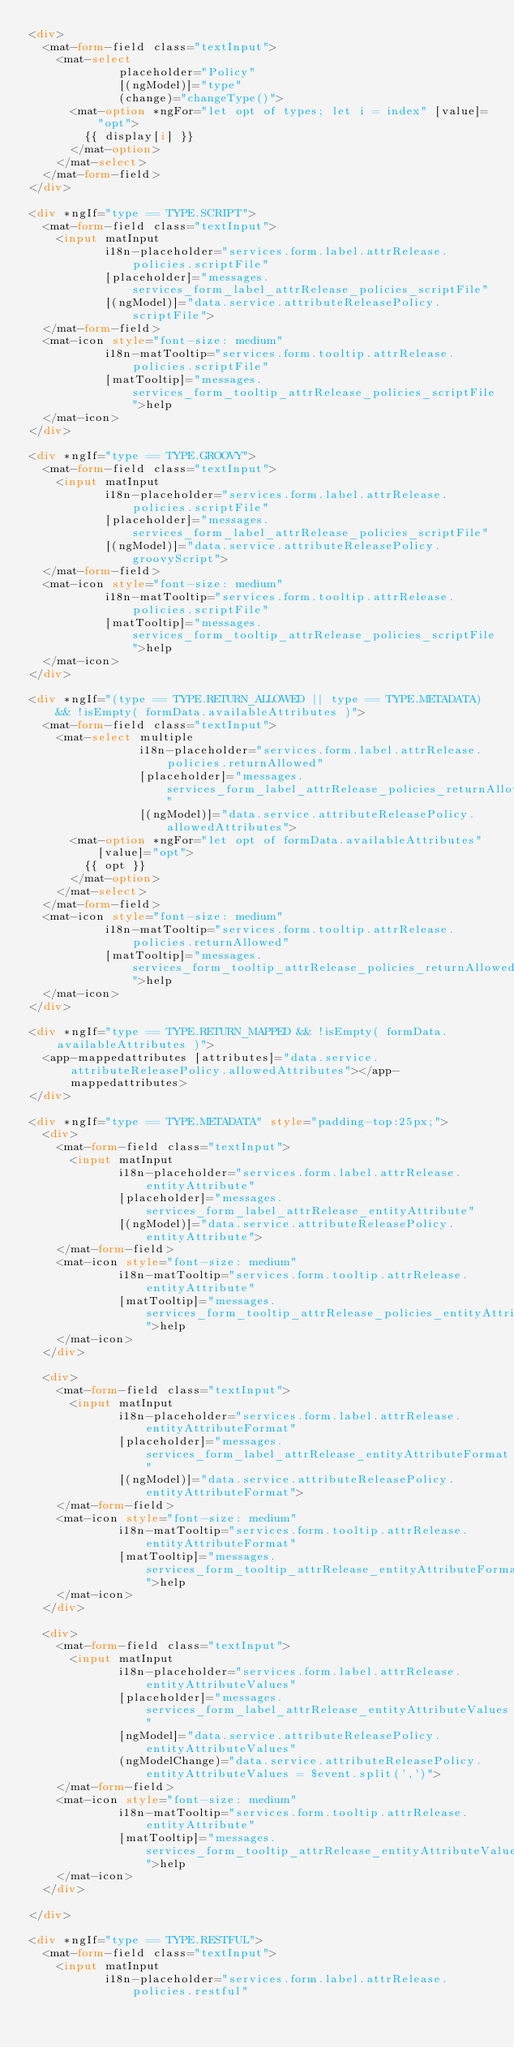<code> <loc_0><loc_0><loc_500><loc_500><_HTML_><div>
  <mat-form-field class="textInput">
    <mat-select
             placeholder="Policy"
             [(ngModel)]="type"
             (change)="changeType()">
      <mat-option *ngFor="let opt of types; let i = index" [value]="opt">
        {{ display[i] }}
      </mat-option>
    </mat-select>
  </mat-form-field>
</div>

<div *ngIf="type == TYPE.SCRIPT">
  <mat-form-field class="textInput">
    <input matInput
           i18n-placeholder="services.form.label.attrRelease.policies.scriptFile"
           [placeholder]="messages.services_form_label_attrRelease_policies_scriptFile"
           [(ngModel)]="data.service.attributeReleasePolicy.scriptFile">
  </mat-form-field>
  <mat-icon style="font-size: medium"
           i18n-matTooltip="services.form.tooltip.attrRelease.policies.scriptFile"
           [matTooltip]="messages.services_form_tooltip_attrRelease_policies_scriptFile">help
  </mat-icon>
</div>

<div *ngIf="type == TYPE.GROOVY">
  <mat-form-field class="textInput">
    <input matInput
           i18n-placeholder="services.form.label.attrRelease.policies.scriptFile"
           [placeholder]="messages.services_form_label_attrRelease_policies_scriptFile"
           [(ngModel)]="data.service.attributeReleasePolicy.groovyScript">
  </mat-form-field>
  <mat-icon style="font-size: medium"
           i18n-matTooltip="services.form.tooltip.attrRelease.policies.scriptFile"
           [matTooltip]="messages.services_form_tooltip_attrRelease_policies_scriptFile">help
  </mat-icon>
</div>

<div *ngIf="(type == TYPE.RETURN_ALLOWED || type == TYPE.METADATA) && !isEmpty( formData.availableAttributes )">
  <mat-form-field class="textInput">
    <mat-select multiple
                i18n-placeholder="services.form.label.attrRelease.policies.returnAllowed"
                [placeholder]="messages.services_form_label_attrRelease_policies_returnAllowed"
                [(ngModel)]="data.service.attributeReleasePolicy.allowedAttributes">
      <mat-option *ngFor="let opt of formData.availableAttributes" [value]="opt">
        {{ opt }}
      </mat-option>
    </mat-select>
  </mat-form-field>
  <mat-icon style="font-size: medium"
           i18n-matTooltip="services.form.tooltip.attrRelease.policies.returnAllowed"
           [matTooltip]="messages.services_form_tooltip_attrRelease_policies_returnAllowed">help
  </mat-icon>
</div>

<div *ngIf="type == TYPE.RETURN_MAPPED && !isEmpty( formData.availableAttributes )">
  <app-mappedattributes [attributes]="data.service.attributeReleasePolicy.allowedAttributes"></app-mappedattributes>
</div>

<div *ngIf="type == TYPE.METADATA" style="padding-top:25px;">
  <div>
    <mat-form-field class="textInput">
      <input matInput
             i18n-placeholder="services.form.label.attrRelease.entityAttribute"
             [placeholder]="messages.services_form_label_attrRelease_entityAttribute"
             [(ngModel)]="data.service.attributeReleasePolicy.entityAttribute">
    </mat-form-field>
    <mat-icon style="font-size: medium"
             i18n-matTooltip="services.form.tooltip.attrRelease.entityAttribute"
             [matTooltip]="messages.services_form_tooltip_attrRelease_policies_entityAttribute">help
    </mat-icon>
  </div>

  <div>
    <mat-form-field class="textInput">
      <input matInput
             i18n-placeholder="services.form.label.attrRelease.entityAttributeFormat"
             [placeholder]="messages.services_form_label_attrRelease_entityAttributeFormat"
             [(ngModel)]="data.service.attributeReleasePolicy.entityAttributeFormat">
    </mat-form-field>
    <mat-icon style="font-size: medium"
             i18n-matTooltip="services.form.tooltip.attrRelease.entityAttributeFormat"
             [matTooltip]="messages.services_form_tooltip_attrRelease_entityAttributeFormat">help
    </mat-icon>
  </div>

  <div>
    <mat-form-field class="textInput">
      <input matInput
             i18n-placeholder="services.form.label.attrRelease.entityAttributeValues"
             [placeholder]="messages.services_form_label_attrRelease_entityAttributeValues"
             [ngModel]="data.service.attributeReleasePolicy.entityAttributeValues"
             (ngModelChange)="data.service.attributeReleasePolicy.entityAttributeValues = $event.split(',')">
    </mat-form-field>
    <mat-icon style="font-size: medium"
             i18n-matTooltip="services.form.tooltip.attrRelease.entityAttribute"
             [matTooltip]="messages.services_form_tooltip_attrRelease_entityAttributeValues">help
    </mat-icon>
  </div>

</div>

<div *ngIf="type == TYPE.RESTFUL">
  <mat-form-field class="textInput">
    <input matInput
           i18n-placeholder="services.form.label.attrRelease.policies.restful"</code> 